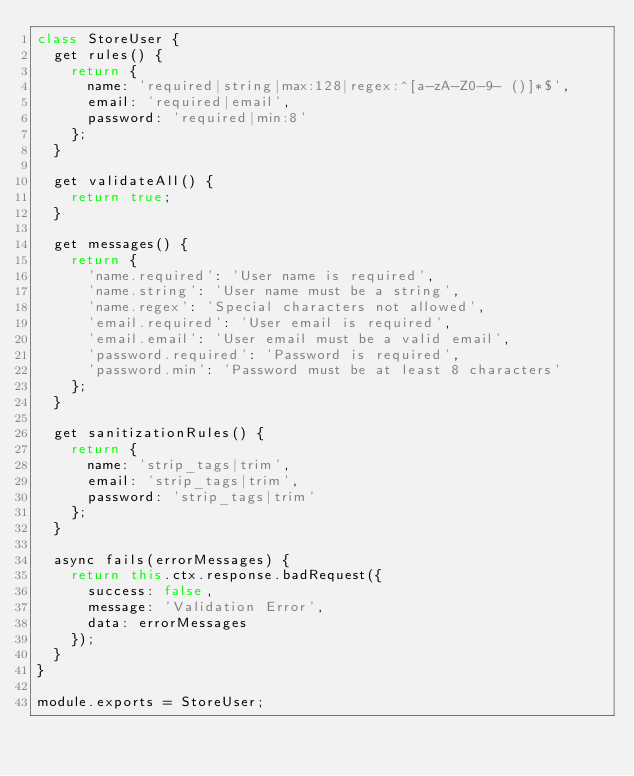<code> <loc_0><loc_0><loc_500><loc_500><_JavaScript_>class StoreUser {
  get rules() {
    return {
      name: 'required|string|max:128|regex:^[a-zA-Z0-9- ()]*$',
      email: 'required|email',
      password: 'required|min:8'
    };
  }

  get validateAll() {
    return true;
  }

  get messages() {
    return {
      'name.required': 'User name is required',
      'name.string': 'User name must be a string',
      'name.regex': 'Special characters not allowed',
      'email.required': 'User email is required',
      'email.email': 'User email must be a valid email',
      'password.required': 'Password is required',
      'password.min': 'Password must be at least 8 characters'
    };
  }

  get sanitizationRules() {
    return {
      name: 'strip_tags|trim',
      email: 'strip_tags|trim',
      password: 'strip_tags|trim'
    };
  }

  async fails(errorMessages) {
    return this.ctx.response.badRequest({
      success: false,
      message: 'Validation Error',
      data: errorMessages
    });
  }
}

module.exports = StoreUser;
</code> 